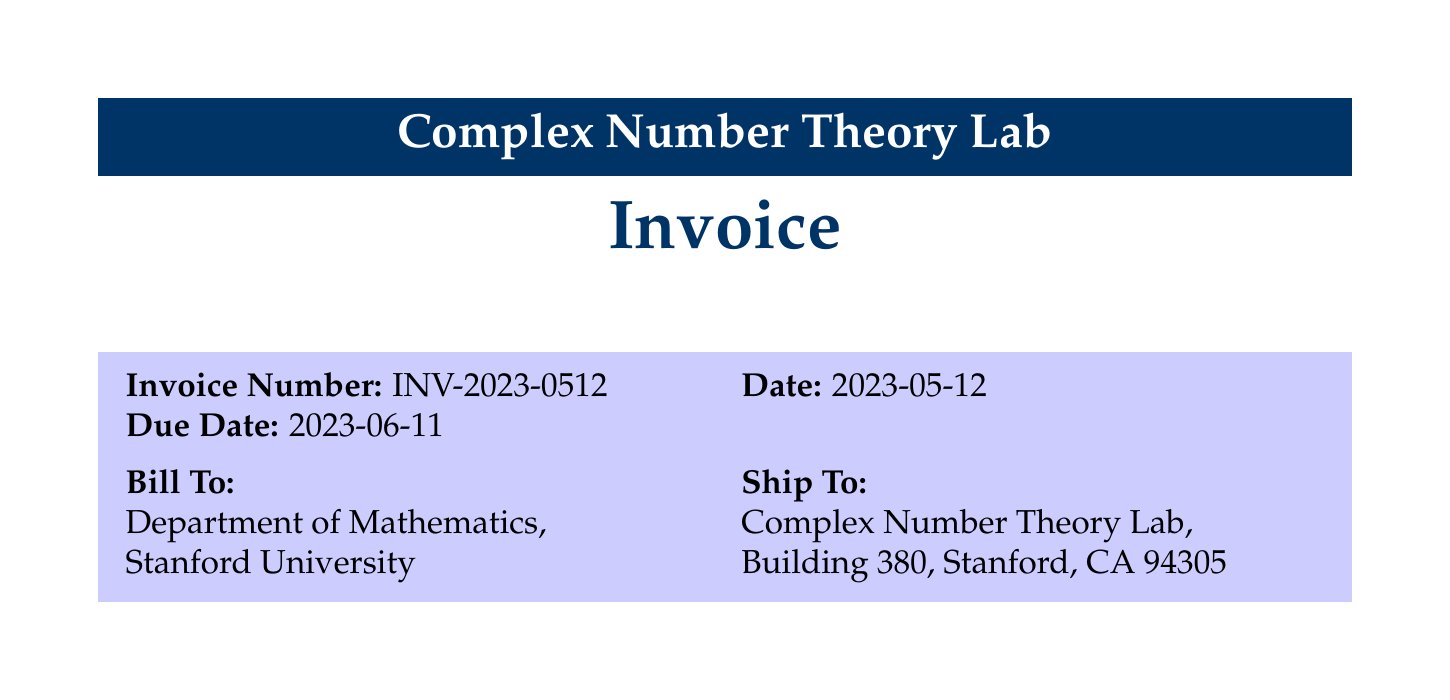what is the invoice number? The invoice number is clearly stated in the document as part of the invoice details.
Answer: INV-2023-0512 what is the total amount? The total amount is the final charge listed at the bottom of the invoice document.
Answer: 121,011.24 how many Dell Precision 7920 Tower Workstations were purchased? The quantity of Dell Precision 7920 Tower Workstations is specified in the items section of the invoice.
Answer: 2 what is the tax rate applied to the invoice? The tax rate is mentioned in the summary section of the invoice as applied to the subtotal.
Answer: 8.75% who is the billing recipient? The billing recipient is indicated at the top of the invoice in the billing section.
Answer: Department of Mathematics, Stanford University what is the subtotal before tax? The subtotal is provided as a distinct line item before tax calculations in the invoice.
Answer: 111,274.70 how many items were listed in total? The total number of items can be counted from the items table in the document.
Answer: 10 what is the payment term specified in the invoice? The payment terms are specifically outlined in the notes section of the invoice.
Answer: Net 30 what is the description of the NVIDIA Tesla V100 GPU? The description provides details about the function and purpose of the GPU as listed in the items section.
Answer: Accelerator for parallel processing in number theory algorithms 